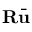Convert formula to latex. <formula><loc_0><loc_0><loc_500><loc_500>R \bar { u }</formula> 